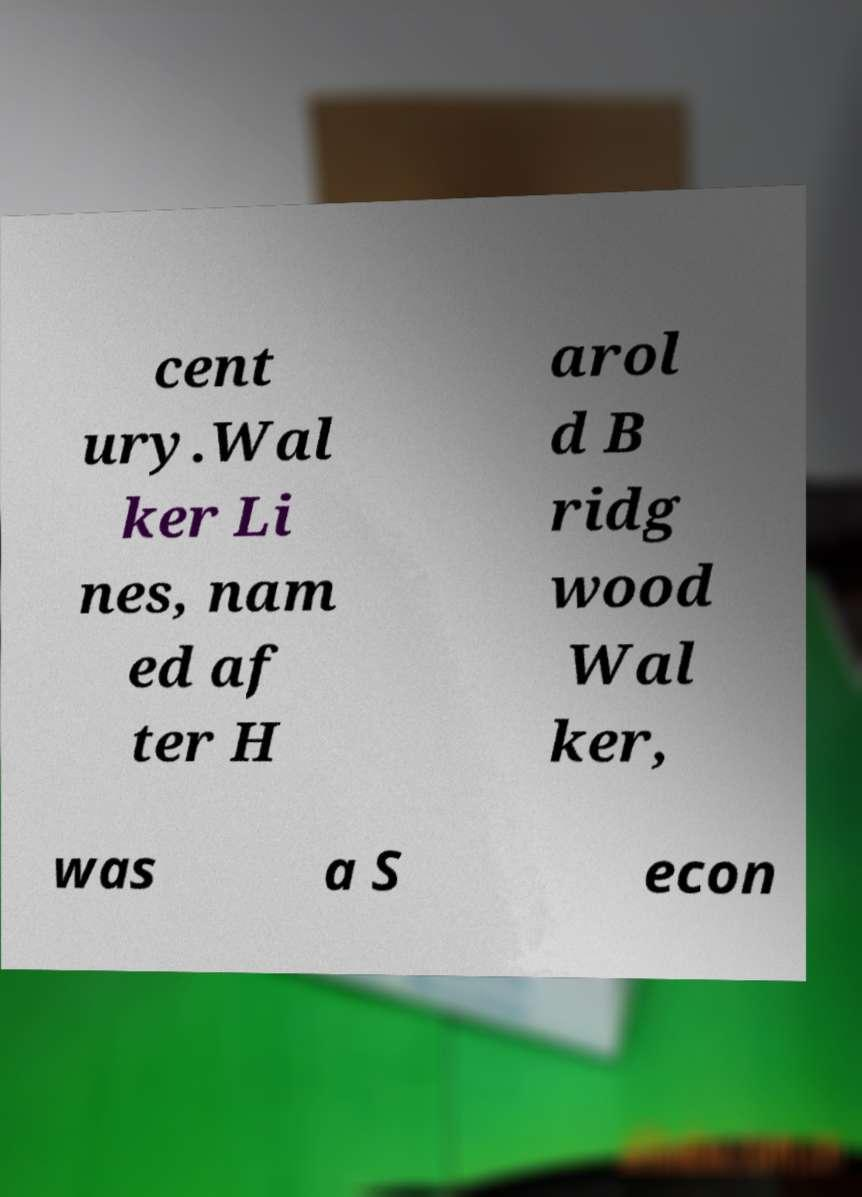Could you assist in decoding the text presented in this image and type it out clearly? cent ury.Wal ker Li nes, nam ed af ter H arol d B ridg wood Wal ker, was a S econ 